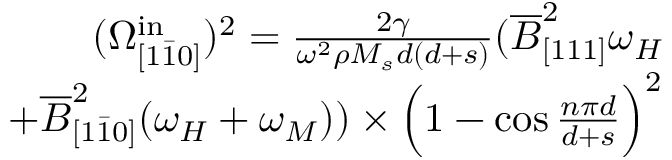Convert formula to latex. <formula><loc_0><loc_0><loc_500><loc_500>\begin{array} { r } { ( \Omega _ { [ 1 \bar { 1 } 0 ] } ^ { i n } ) ^ { 2 } = \frac { 2 \gamma } { \omega ^ { 2 } \rho M _ { s } d ( d + s ) } ( \overline { B } _ { [ 1 1 1 ] } ^ { 2 } \omega _ { H } } \\ { + \overline { B } _ { [ 1 \bar { 1 } 0 ] } ^ { 2 } ( \omega _ { H } + \omega _ { M } ) ) \times \left ( 1 - \cos { \frac { n \pi d } { d + s } } \right ) ^ { 2 } } \end{array}</formula> 